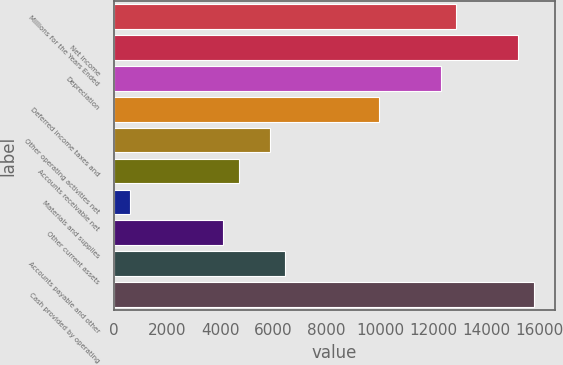<chart> <loc_0><loc_0><loc_500><loc_500><bar_chart><fcel>Millions for the Years Ended<fcel>Net income<fcel>Depreciation<fcel>Deferred income taxes and<fcel>Other operating activities net<fcel>Accounts receivable net<fcel>Materials and supplies<fcel>Other current assets<fcel>Accounts payable and other<fcel>Cash provided by operating<nl><fcel>12859.4<fcel>15188.2<fcel>12277.2<fcel>9948.4<fcel>5873<fcel>4708.6<fcel>633.2<fcel>4126.4<fcel>6455.2<fcel>15770.4<nl></chart> 